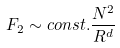<formula> <loc_0><loc_0><loc_500><loc_500>F _ { 2 } \sim c o n s t . \frac { N ^ { 2 } } { R ^ { d } }</formula> 